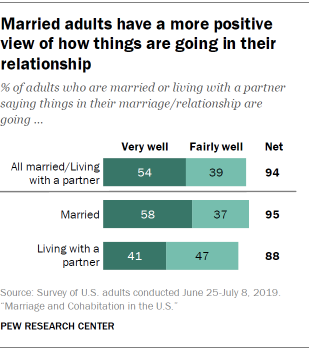List a handful of essential elements in this visual. According to a recent survey, 37% of married individuals consider themselves to be fairly well-off financially. Of the Fairly well bars with a score above 37, the sum is 86. 